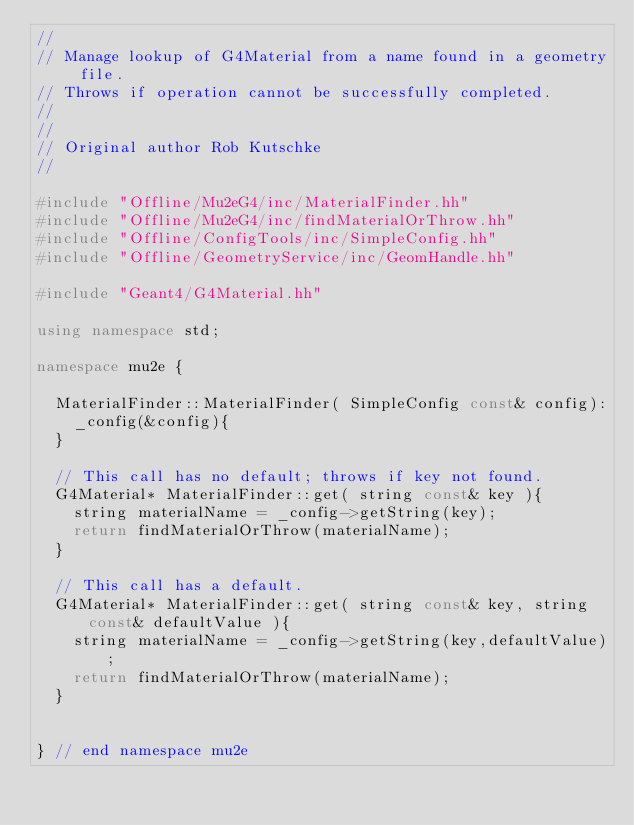<code> <loc_0><loc_0><loc_500><loc_500><_C++_>//
// Manage lookup of G4Material from a name found in a geometry file.
// Throws if operation cannot be successfully completed.
//
//
// Original author Rob Kutschke
//

#include "Offline/Mu2eG4/inc/MaterialFinder.hh"
#include "Offline/Mu2eG4/inc/findMaterialOrThrow.hh"
#include "Offline/ConfigTools/inc/SimpleConfig.hh"
#include "Offline/GeometryService/inc/GeomHandle.hh"

#include "Geant4/G4Material.hh"

using namespace std;

namespace mu2e {

  MaterialFinder::MaterialFinder( SimpleConfig const& config):
    _config(&config){
  }

  // This call has no default; throws if key not found.
  G4Material* MaterialFinder::get( string const& key ){
    string materialName = _config->getString(key);
    return findMaterialOrThrow(materialName);
  }

  // This call has a default.
  G4Material* MaterialFinder::get( string const& key, string const& defaultValue ){
    string materialName = _config->getString(key,defaultValue);
    return findMaterialOrThrow(materialName);
  }


} // end namespace mu2e
</code> 